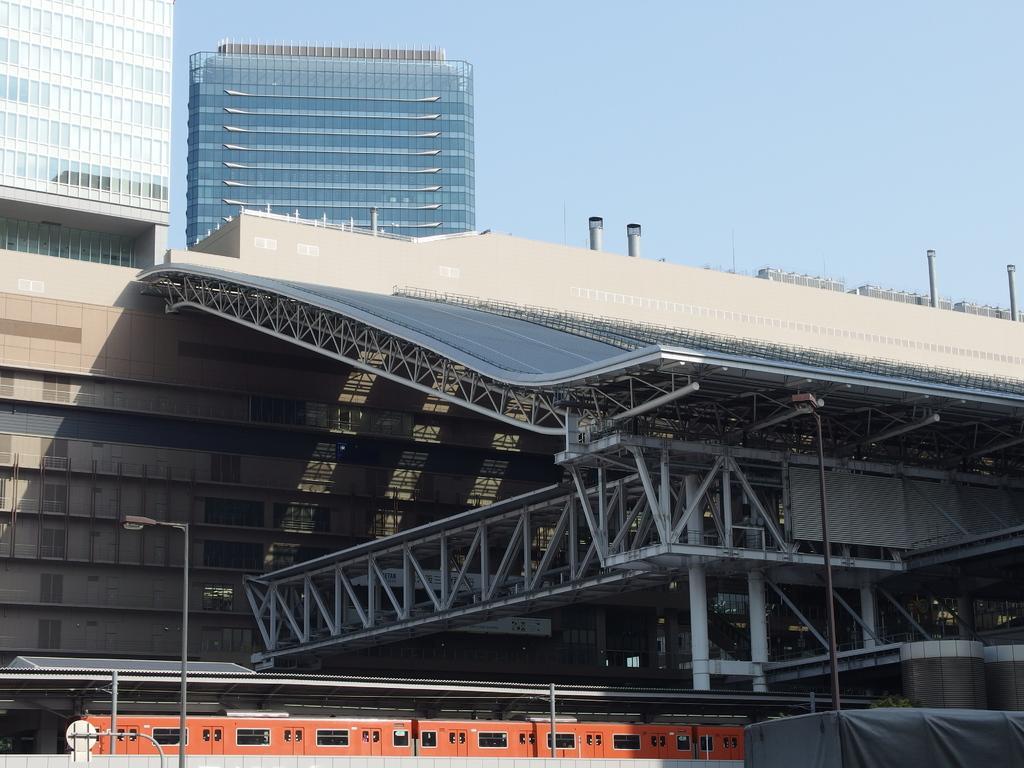Can you describe this image briefly? In this image we can see buildings, metal shed, bridge, street light, train and in the background we can see the sky. 